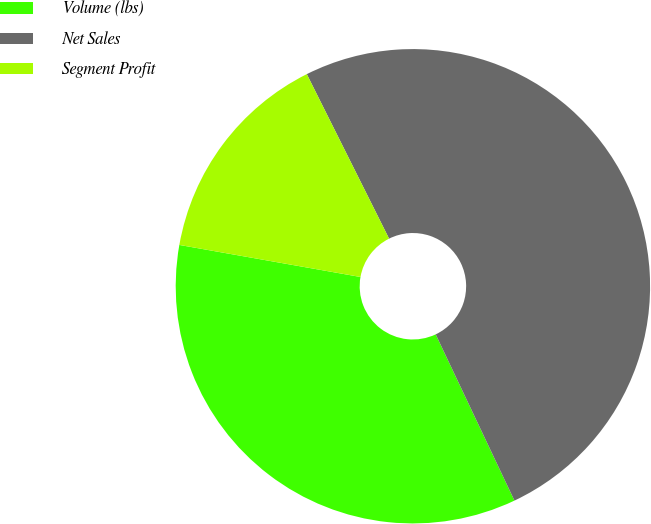Convert chart. <chart><loc_0><loc_0><loc_500><loc_500><pie_chart><fcel>Volume (lbs)<fcel>Net Sales<fcel>Segment Profit<nl><fcel>34.83%<fcel>50.34%<fcel>14.83%<nl></chart> 